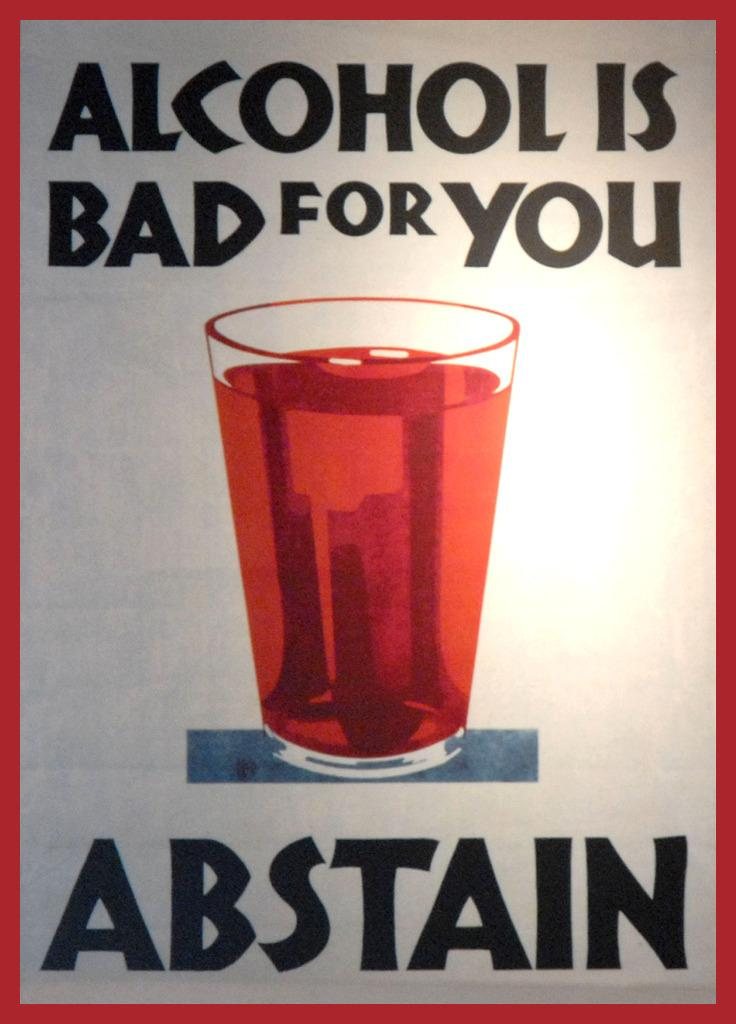Provide a one-sentence caption for the provided image. A sign or poster encouraging abstinence from consuming alcohol. 